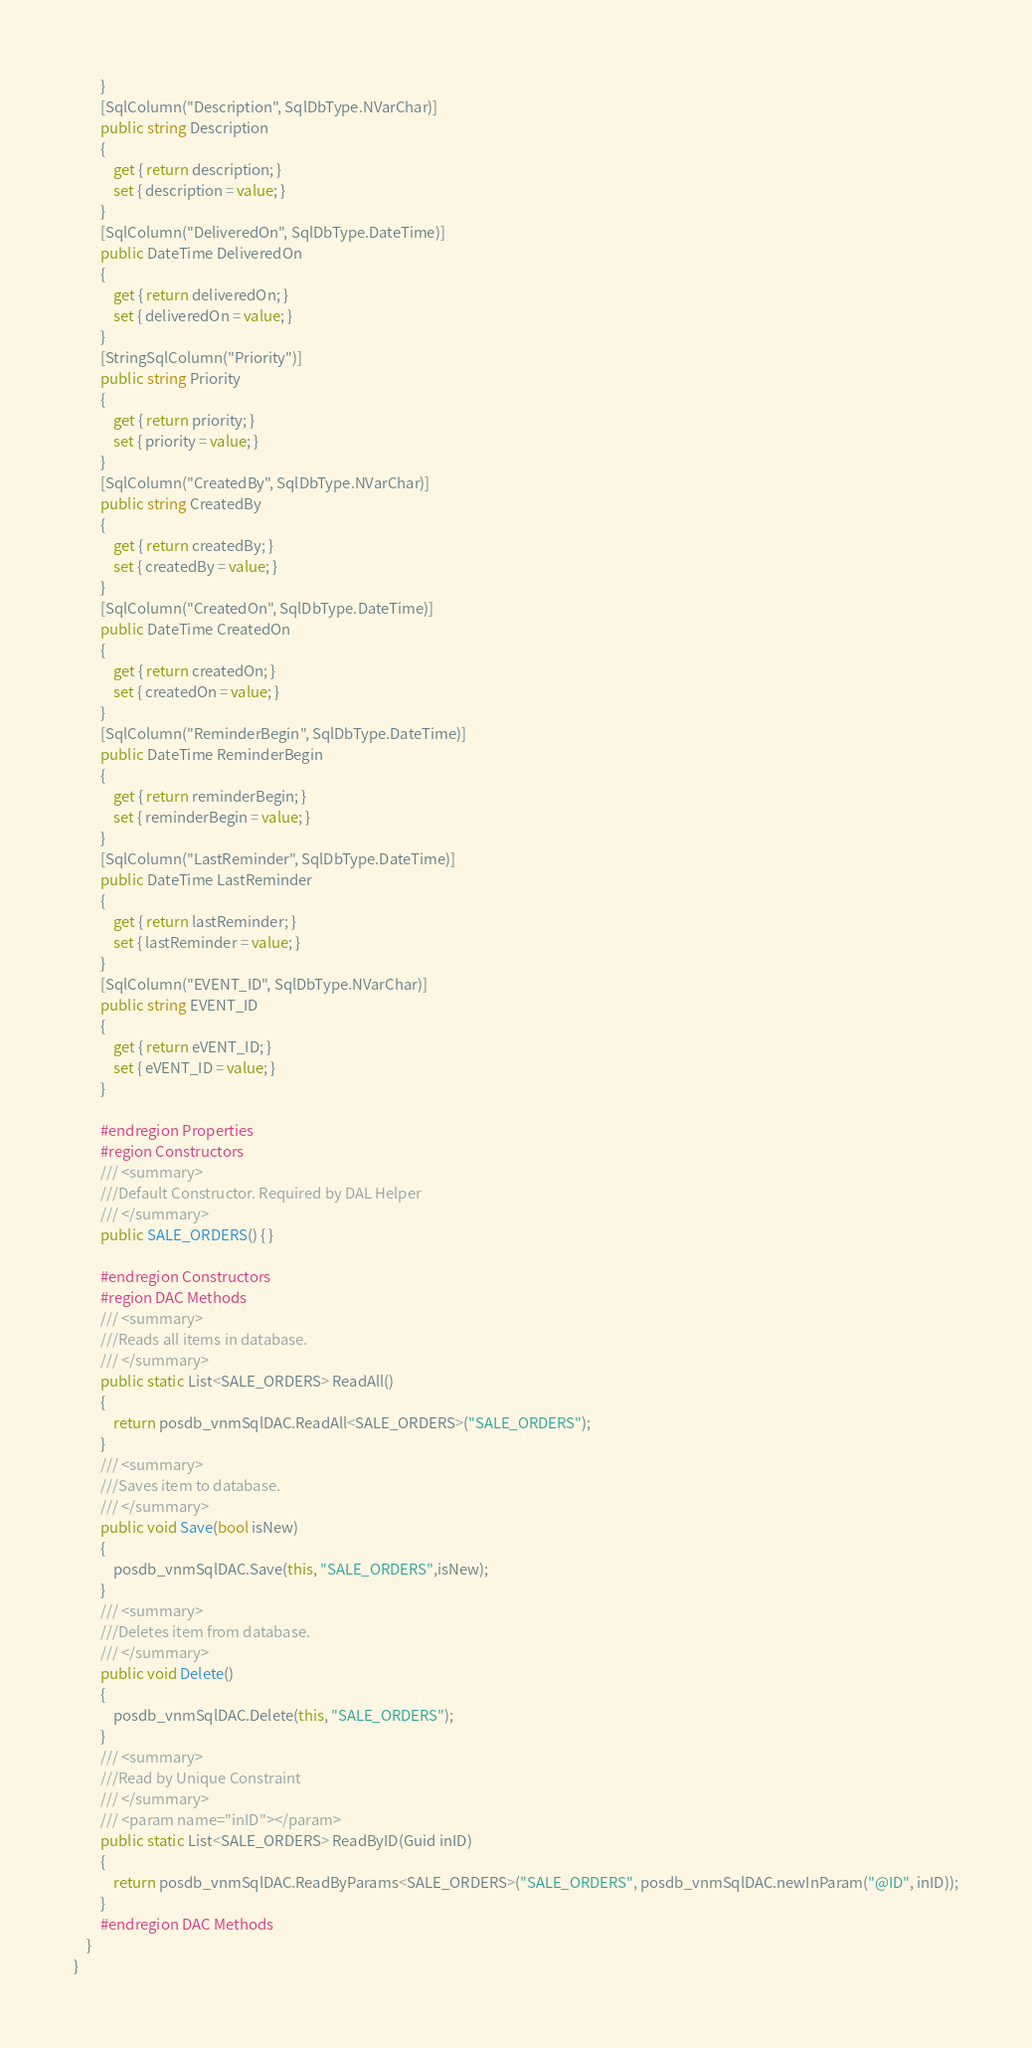Convert code to text. <code><loc_0><loc_0><loc_500><loc_500><_C#_>        }
        [SqlColumn("Description", SqlDbType.NVarChar)]
        public string Description
        {
            get { return description; }
            set { description = value; }
        }
        [SqlColumn("DeliveredOn", SqlDbType.DateTime)]
        public DateTime DeliveredOn
        {
            get { return deliveredOn; }
            set { deliveredOn = value; }
        }
        [StringSqlColumn("Priority")]
        public string Priority
        {
            get { return priority; }
            set { priority = value; }
        }
        [SqlColumn("CreatedBy", SqlDbType.NVarChar)]
        public string CreatedBy
        {
            get { return createdBy; }
            set { createdBy = value; }
        }
        [SqlColumn("CreatedOn", SqlDbType.DateTime)]
        public DateTime CreatedOn
        {
            get { return createdOn; }
            set { createdOn = value; }
        }
        [SqlColumn("ReminderBegin", SqlDbType.DateTime)]
        public DateTime ReminderBegin
        {
            get { return reminderBegin; }
            set { reminderBegin = value; }
        }
        [SqlColumn("LastReminder", SqlDbType.DateTime)]
        public DateTime LastReminder
        {
            get { return lastReminder; }
            set { lastReminder = value; }
        }
        [SqlColumn("EVENT_ID", SqlDbType.NVarChar)]
        public string EVENT_ID
        {
            get { return eVENT_ID; }
            set { eVENT_ID = value; }
        }

        #endregion Properties
        #region Constructors
        /// <summary>
        ///Default Constructor. Required by DAL Helper
        /// </summary>
        public SALE_ORDERS() { }

        #endregion Constructors
        #region DAC Methods
        /// <summary>
        ///Reads all items in database.
        /// </summary>
        public static List<SALE_ORDERS> ReadAll()
        {
            return posdb_vnmSqlDAC.ReadAll<SALE_ORDERS>("SALE_ORDERS");
        }
        /// <summary>
        ///Saves item to database.
        /// </summary>
        public void Save(bool isNew)
        {
            posdb_vnmSqlDAC.Save(this, "SALE_ORDERS",isNew);
        }
        /// <summary>
        ///Deletes item from database.
        /// </summary>
        public void Delete()
        {
            posdb_vnmSqlDAC.Delete(this, "SALE_ORDERS");
        }
        /// <summary>
        ///Read by Unique Constraint
        /// </summary>
        /// <param name="inID"></param>
        public static List<SALE_ORDERS> ReadByID(Guid inID)
        {
            return posdb_vnmSqlDAC.ReadByParams<SALE_ORDERS>("SALE_ORDERS", posdb_vnmSqlDAC.newInParam("@ID", inID));
        }
        #endregion DAC Methods
    }
}
</code> 